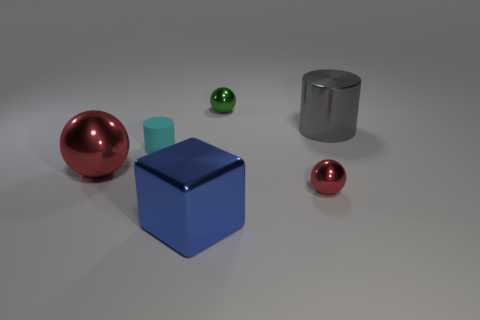Is the tiny rubber cylinder the same color as the large metallic cylinder?
Give a very brief answer. No. What is the shape of the thing that is the same color as the big ball?
Give a very brief answer. Sphere. There is a tiny object behind the big gray metal object; how many tiny matte cylinders are on the right side of it?
Keep it short and to the point. 0. How many big cyan blocks have the same material as the gray cylinder?
Give a very brief answer. 0. Are there any tiny green things to the right of the cyan rubber object?
Your answer should be very brief. Yes. The metallic sphere that is the same size as the blue thing is what color?
Make the answer very short. Red. What number of objects are either shiny spheres in front of the big gray object or green things?
Your answer should be very brief. 3. What size is the ball that is both to the right of the large blue cube and in front of the big gray shiny object?
Keep it short and to the point. Small. What size is the shiny thing that is the same color as the big ball?
Ensure brevity in your answer.  Small. What number of other things are there of the same size as the cube?
Provide a short and direct response. 2. 